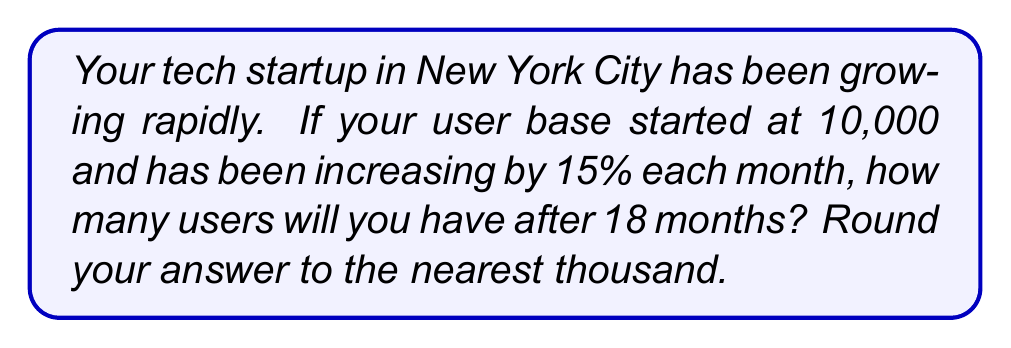Solve this math problem. Let's approach this step-by-step using an exponential growth model:

1) The exponential growth function is given by:
   $$A(t) = A_0(1 + r)^t$$
   where:
   $A(t)$ is the amount after time $t$
   $A_0$ is the initial amount
   $r$ is the growth rate (as a decimal)
   $t$ is the time period

2) In this case:
   $A_0 = 10,000$ (initial users)
   $r = 0.15$ (15% monthly growth rate)
   $t = 18$ (months)

3) Plugging these values into our equation:
   $$A(18) = 10,000(1 + 0.15)^{18}$$

4) Simplify:
   $$A(18) = 10,000(1.15)^{18}$$

5) Calculate:
   $$A(18) = 10,000 * 13.0069...$$
   $$A(18) = 130,069...$$

6) Rounding to the nearest thousand:
   $$A(18) \approx 130,000$$
Answer: 130,000 users 